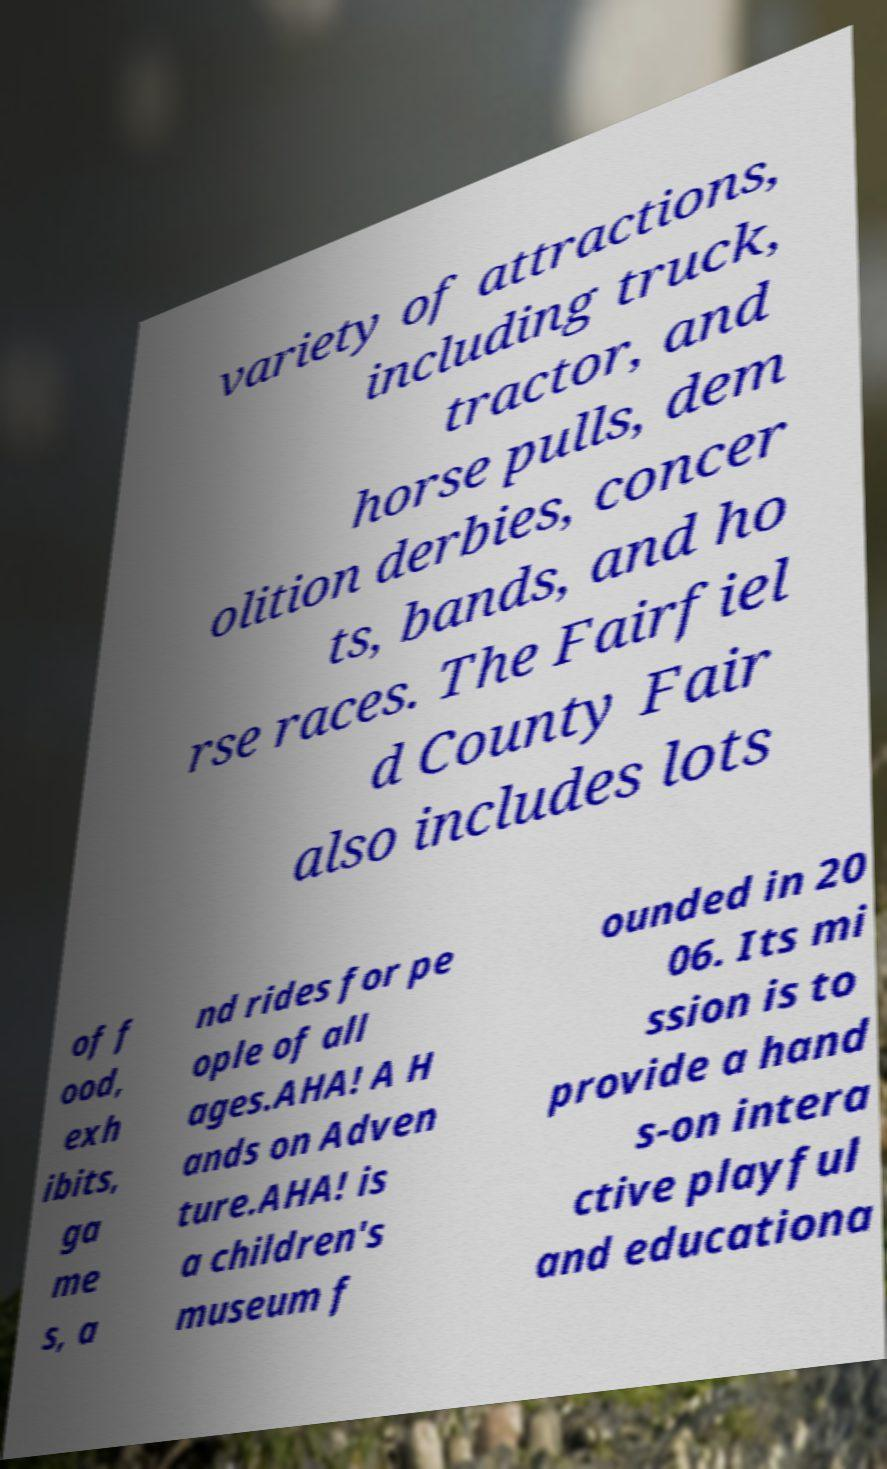I need the written content from this picture converted into text. Can you do that? variety of attractions, including truck, tractor, and horse pulls, dem olition derbies, concer ts, bands, and ho rse races. The Fairfiel d County Fair also includes lots of f ood, exh ibits, ga me s, a nd rides for pe ople of all ages.AHA! A H ands on Adven ture.AHA! is a children's museum f ounded in 20 06. Its mi ssion is to provide a hand s-on intera ctive playful and educationa 